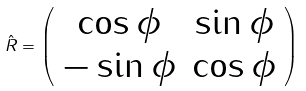Convert formula to latex. <formula><loc_0><loc_0><loc_500><loc_500>\hat { R } = \left ( \begin{array} { c c } \cos \phi & \sin \phi \\ - \sin \phi & \cos \phi \end{array} \right )</formula> 